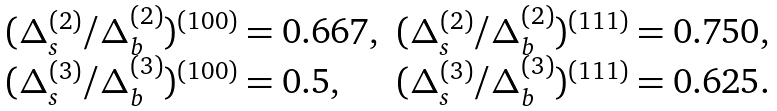<formula> <loc_0><loc_0><loc_500><loc_500>\begin{array} { l l } ( \Delta ^ { ( 2 ) } _ { s } / \Delta ^ { ( 2 ) } _ { b } ) ^ { ( 1 0 0 ) } = 0 . 6 6 7 , & ( \Delta ^ { ( 2 ) } _ { s } / \Delta ^ { ( 2 ) } _ { b } ) ^ { ( 1 1 1 ) } = 0 . 7 5 0 , \\ ( \Delta ^ { ( 3 ) } _ { s } / \Delta ^ { ( 3 ) } _ { b } ) ^ { ( 1 0 0 ) } = 0 . 5 , & ( \Delta ^ { ( 3 ) } _ { s } / \Delta ^ { ( 3 ) } _ { b } ) ^ { ( 1 1 1 ) } = 0 . 6 2 5 . \\ \end{array}</formula> 